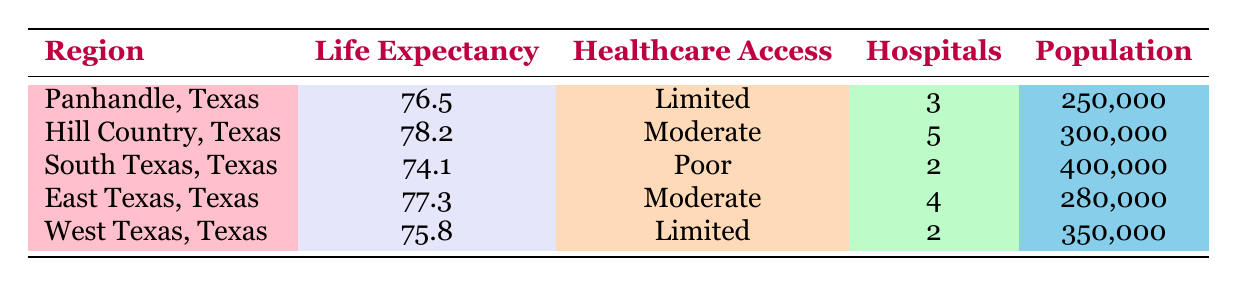What is the average life expectancy in the Panhandle, Texas? The life expectancy for the Panhandle, Texas is explicitly stated in the table as 76.5.
Answer: 76.5 How many hospitals are there in South Texas, Texas? The table indicates that there are 2 hospitals in South Texas, Texas.
Answer: 2 Is the healthcare access in Hill Country, Texas considered poor? According to the table, Hill Country, Texas has a moderate level of healthcare access, not poor.
Answer: No Which region has the highest average life expectancy? Comparing the life expectancies across all regions, Hill Country, Texas has the highest life expectancy at 78.2.
Answer: Hill Country, Texas What is the total number of hospitals in East Texas and West Texas combined? For East Texas, there are 4 hospitals, and for West Texas, there are 2 hospitals. Adding these together gives 4 + 2 = 6 hospitals.
Answer: 6 If the population of South Texas, Texas is 400,000, what is the average life expectancy per 100,000 people? The average life expectancy in South Texas is 74.1, and since life expectancy does not depend on population size, it remains the same regardless of the population. Thus, for any size, it's still 74.1.
Answer: 74.1 Do regions with limited healthcare access have higher life expectancy than those with poor access? By examining the data, the two regions with limited access (Panhandle and West Texas) have life expectancies of 76.5 and 75.8, respectively. The region with poor access (South Texas) has a life expectancy of 74.1. Therefore, limited access regions have a higher life expectancy.
Answer: Yes What is the average life expectancy of regions with moderate access to healthcare facilities? The regions with moderate access are Hill Country and East Texas. Their life expectancies are 78.2 and 77.3, respectively. To calculate the average, sum them (78.2 + 77.3 = 155.5) and divide by 2, yielding 155.5 / 2 = 77.75.
Answer: 77.75 Which region has the largest population and what is its average life expectancy? According to the table, South Texas has the largest population at 400,000, and its average life expectancy is 74.1.
Answer: South Texas, 74.1 